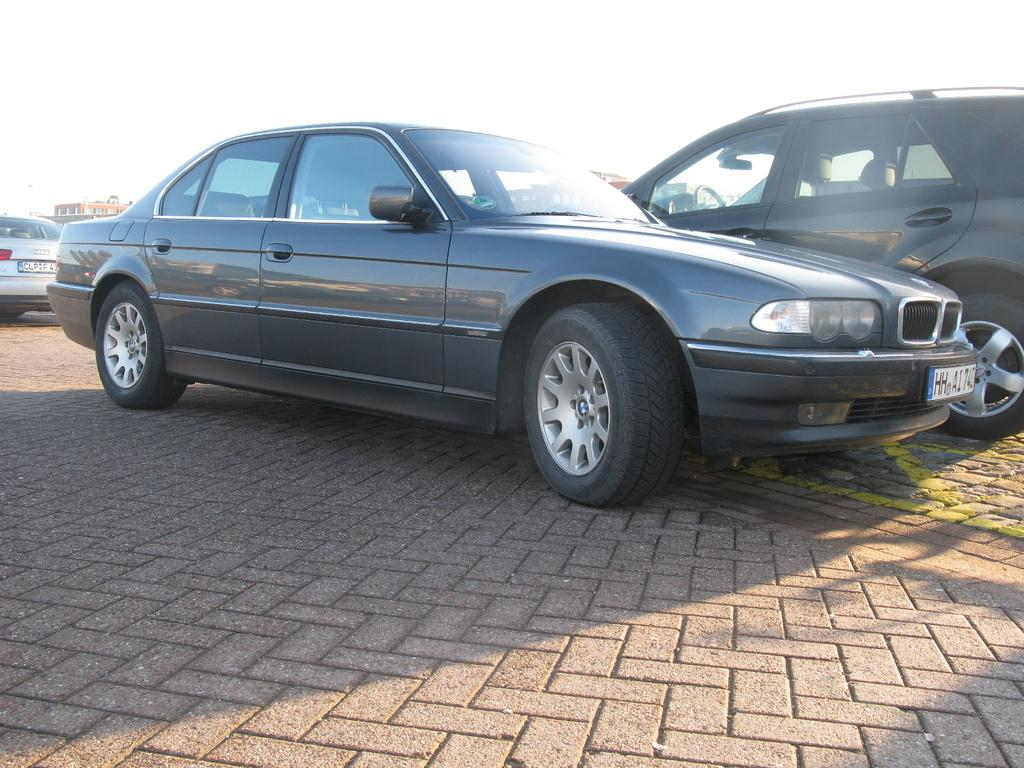What type of vehicles can be seen in the image? There are cars in the image. What can be seen in the distance behind the cars? There are buildings in the background of the image. Where is the kitten playing with the cable in the image? There is no kitten or cable present in the image. 